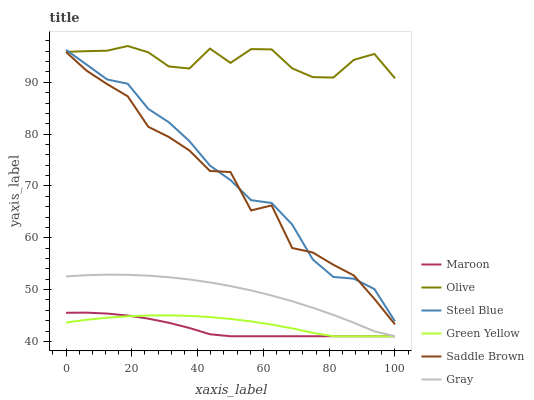Does Maroon have the minimum area under the curve?
Answer yes or no. Yes. Does Olive have the maximum area under the curve?
Answer yes or no. Yes. Does Steel Blue have the minimum area under the curve?
Answer yes or no. No. Does Steel Blue have the maximum area under the curve?
Answer yes or no. No. Is Green Yellow the smoothest?
Answer yes or no. Yes. Is Saddle Brown the roughest?
Answer yes or no. Yes. Is Steel Blue the smoothest?
Answer yes or no. No. Is Steel Blue the roughest?
Answer yes or no. No. Does Gray have the lowest value?
Answer yes or no. Yes. Does Steel Blue have the lowest value?
Answer yes or no. No. Does Olive have the highest value?
Answer yes or no. Yes. Does Steel Blue have the highest value?
Answer yes or no. No. Is Gray less than Steel Blue?
Answer yes or no. Yes. Is Olive greater than Saddle Brown?
Answer yes or no. Yes. Does Olive intersect Steel Blue?
Answer yes or no. Yes. Is Olive less than Steel Blue?
Answer yes or no. No. Is Olive greater than Steel Blue?
Answer yes or no. No. Does Gray intersect Steel Blue?
Answer yes or no. No. 